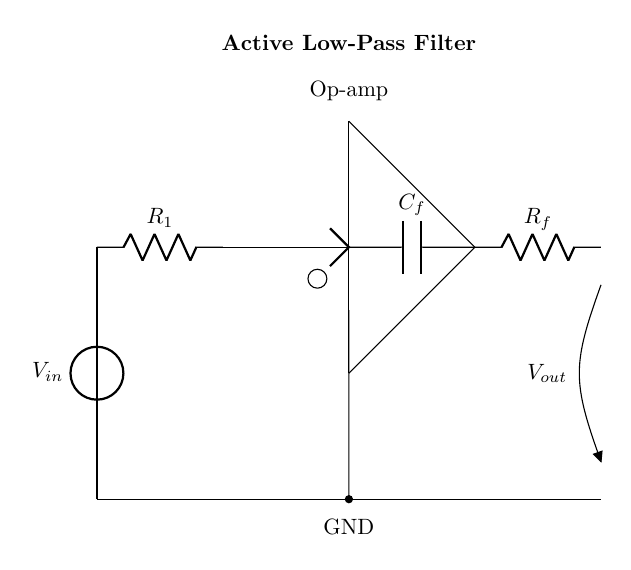What components are present in this circuit? The circuit includes a voltage source, a resistor, an operational amplifier, a capacitor, and another resistor. These components are connected to form an active low-pass filter.
Answer: Voltage source, resistor, op-amp, capacitor, resistor What is the purpose of the capacitor in this circuit? The capacitor serves as a feedback element in the op-amp configuration, which helps to set the cutoff frequency of the low-pass filter and smooths the output voltage.
Answer: Feedback element What is the type of filter implemented in this circuit? The implemented filter is a low-pass filter, as it allows low-frequency signals to pass while attenuating high-frequency signals.
Answer: Low-pass filter What type of operational amplifier configuration is used here? The operational amplifier is configured as a non-inverting amplifier because the input is connected to the non-inverting terminal.
Answer: Non-inverting How does the resistor affect the cutoff frequency in this filter? The resistor in conjunction with the capacitor determines the cutoff frequency of the filter, following the formula for the cutoff frequency depending on the resistance and capacitance values.
Answer: It sets the cutoff frequency What occurs at the output of the circuit as frequency increases? As frequency increases, the output voltage decreases due to high-frequency signals being attenuated by the low-pass filter characteristics of the circuit.
Answer: Decreased output voltage What is the voltage at the output when the input is at zero frequency? When the input frequency is zero, the output voltage approaches the value of the input voltage because the filter allows DC signals to pass through with little to no attenuation.
Answer: Input voltage 